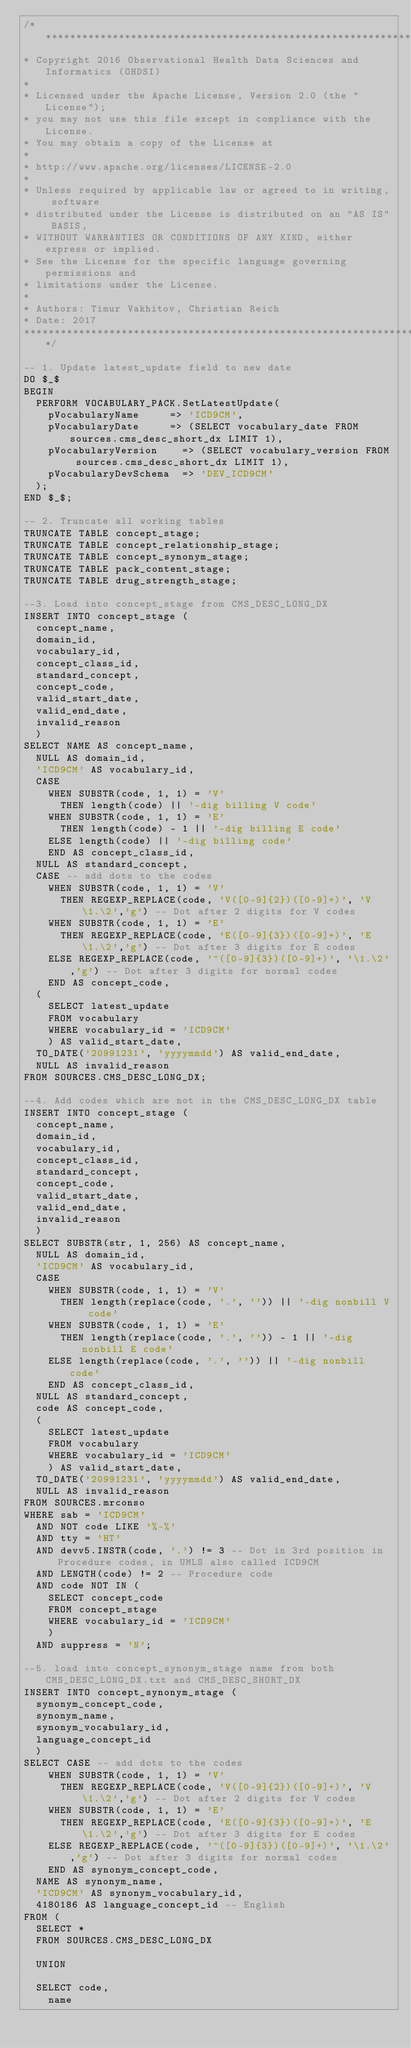Convert code to text. <code><loc_0><loc_0><loc_500><loc_500><_SQL_>/**************************************************************************
* Copyright 2016 Observational Health Data Sciences and Informatics (OHDSI)
*
* Licensed under the Apache License, Version 2.0 (the "License");
* you may not use this file except in compliance with the License.
* You may obtain a copy of the License at
*
* http://www.apache.org/licenses/LICENSE-2.0
*
* Unless required by applicable law or agreed to in writing, software
* distributed under the License is distributed on an "AS IS" BASIS,
* WITHOUT WARRANTIES OR CONDITIONS OF ANY KIND, either express or implied.
* See the License for the specific language governing permissions and
* limitations under the License.
* 
* Authors: Timur Vakhitov, Christian Reich
* Date: 2017
**************************************************************************/

-- 1. Update latest_update field to new date
DO $_$
BEGIN
	PERFORM VOCABULARY_PACK.SetLatestUpdate(
		pVocabularyName			=> 'ICD9CM',
		pVocabularyDate			=> (SELECT vocabulary_date FROM sources.cms_desc_short_dx LIMIT 1),
		pVocabularyVersion		=> (SELECT vocabulary_version FROM sources.cms_desc_short_dx LIMIT 1),
		pVocabularyDevSchema	=> 'DEV_ICD9CM'
	);
END $_$;

-- 2. Truncate all working tables
TRUNCATE TABLE concept_stage;
TRUNCATE TABLE concept_relationship_stage;
TRUNCATE TABLE concept_synonym_stage;
TRUNCATE TABLE pack_content_stage;
TRUNCATE TABLE drug_strength_stage;

--3. Load into concept_stage from CMS_DESC_LONG_DX
INSERT INTO concept_stage (
	concept_name,
	domain_id,
	vocabulary_id,
	concept_class_id,
	standard_concept,
	concept_code,
	valid_start_date,
	valid_end_date,
	invalid_reason
	)
SELECT NAME AS concept_name,
	NULL AS domain_id,
	'ICD9CM' AS vocabulary_id,
	CASE 
		WHEN SUBSTR(code, 1, 1) = 'V'
			THEN length(code) || '-dig billing V code'
		WHEN SUBSTR(code, 1, 1) = 'E'
			THEN length(code) - 1 || '-dig billing E code'
		ELSE length(code) || '-dig billing code'
		END AS concept_class_id,
	NULL AS standard_concept,
	CASE -- add dots to the codes
		WHEN SUBSTR(code, 1, 1) = 'V'
			THEN REGEXP_REPLACE(code, 'V([0-9]{2})([0-9]+)', 'V\1.\2','g') -- Dot after 2 digits for V codes
		WHEN SUBSTR(code, 1, 1) = 'E'
			THEN REGEXP_REPLACE(code, 'E([0-9]{3})([0-9]+)', 'E\1.\2','g') -- Dot after 3 digits for E codes
		ELSE REGEXP_REPLACE(code, '^([0-9]{3})([0-9]+)', '\1.\2','g') -- Dot after 3 digits for normal codes
		END AS concept_code,
	(
		SELECT latest_update
		FROM vocabulary
		WHERE vocabulary_id = 'ICD9CM'
		) AS valid_start_date,
	TO_DATE('20991231', 'yyyymmdd') AS valid_end_date,
	NULL AS invalid_reason
FROM SOURCES.CMS_DESC_LONG_DX;

--4. Add codes which are not in the CMS_DESC_LONG_DX table
INSERT INTO concept_stage (
	concept_name,
	domain_id,
	vocabulary_id,
	concept_class_id,
	standard_concept,
	concept_code,
	valid_start_date,
	valid_end_date,
	invalid_reason
	)
SELECT SUBSTR(str, 1, 256) AS concept_name,
	NULL AS domain_id,
	'ICD9CM' AS vocabulary_id,
	CASE 
		WHEN SUBSTR(code, 1, 1) = 'V'
			THEN length(replace(code, '.', '')) || '-dig nonbill V code'
		WHEN SUBSTR(code, 1, 1) = 'E'
			THEN length(replace(code, '.', '')) - 1 || '-dig nonbill E code'
		ELSE length(replace(code, '.', '')) || '-dig nonbill code'
		END AS concept_class_id,
	NULL AS standard_concept,
	code AS concept_code,
	(
		SELECT latest_update
		FROM vocabulary
		WHERE vocabulary_id = 'ICD9CM'
		) AS valid_start_date,
	TO_DATE('20991231', 'yyyymmdd') AS valid_end_date,
	NULL AS invalid_reason
FROM SOURCES.mrconso
WHERE sab = 'ICD9CM'
	AND NOT code LIKE '%-%'
	AND tty = 'HT'
	AND devv5.INSTR(code, '.') != 3 -- Dot in 3rd position in Procedure codes, in UMLS also called ICD9CM
	AND LENGTH(code) != 2 -- Procedure code
	AND code NOT IN (
		SELECT concept_code
		FROM concept_stage
		WHERE vocabulary_id = 'ICD9CM'
		)
	AND suppress = 'N';

--5. load into concept_synonym_stage name from both CMS_DESC_LONG_DX.txt and CMS_DESC_SHORT_DX
INSERT INTO concept_synonym_stage (
	synonym_concept_code,
	synonym_name,
	synonym_vocabulary_id,
	language_concept_id
	)
SELECT CASE -- add dots to the codes
		WHEN SUBSTR(code, 1, 1) = 'V'
			THEN REGEXP_REPLACE(code, 'V([0-9]{2})([0-9]+)', 'V\1.\2','g') -- Dot after 2 digits for V codes
		WHEN SUBSTR(code, 1, 1) = 'E'
			THEN REGEXP_REPLACE(code, 'E([0-9]{3})([0-9]+)', 'E\1.\2','g') -- Dot after 3 digits for E codes
		ELSE REGEXP_REPLACE(code, '^([0-9]{3})([0-9]+)', '\1.\2','g') -- Dot after 3 digits for normal codes
		END AS synonym_concept_code,
	NAME AS synonym_name,
	'ICD9CM' AS synonym_vocabulary_id,
	4180186 AS language_concept_id -- English
FROM (
	SELECT *
	FROM SOURCES.CMS_DESC_LONG_DX
	
	UNION
	
	SELECT code,
		name</code> 